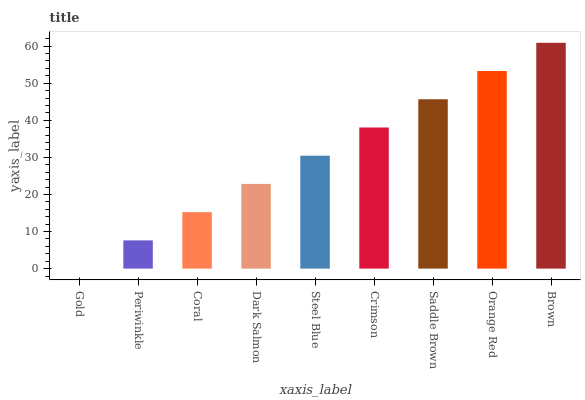Is Gold the minimum?
Answer yes or no. Yes. Is Brown the maximum?
Answer yes or no. Yes. Is Periwinkle the minimum?
Answer yes or no. No. Is Periwinkle the maximum?
Answer yes or no. No. Is Periwinkle greater than Gold?
Answer yes or no. Yes. Is Gold less than Periwinkle?
Answer yes or no. Yes. Is Gold greater than Periwinkle?
Answer yes or no. No. Is Periwinkle less than Gold?
Answer yes or no. No. Is Steel Blue the high median?
Answer yes or no. Yes. Is Steel Blue the low median?
Answer yes or no. Yes. Is Orange Red the high median?
Answer yes or no. No. Is Dark Salmon the low median?
Answer yes or no. No. 